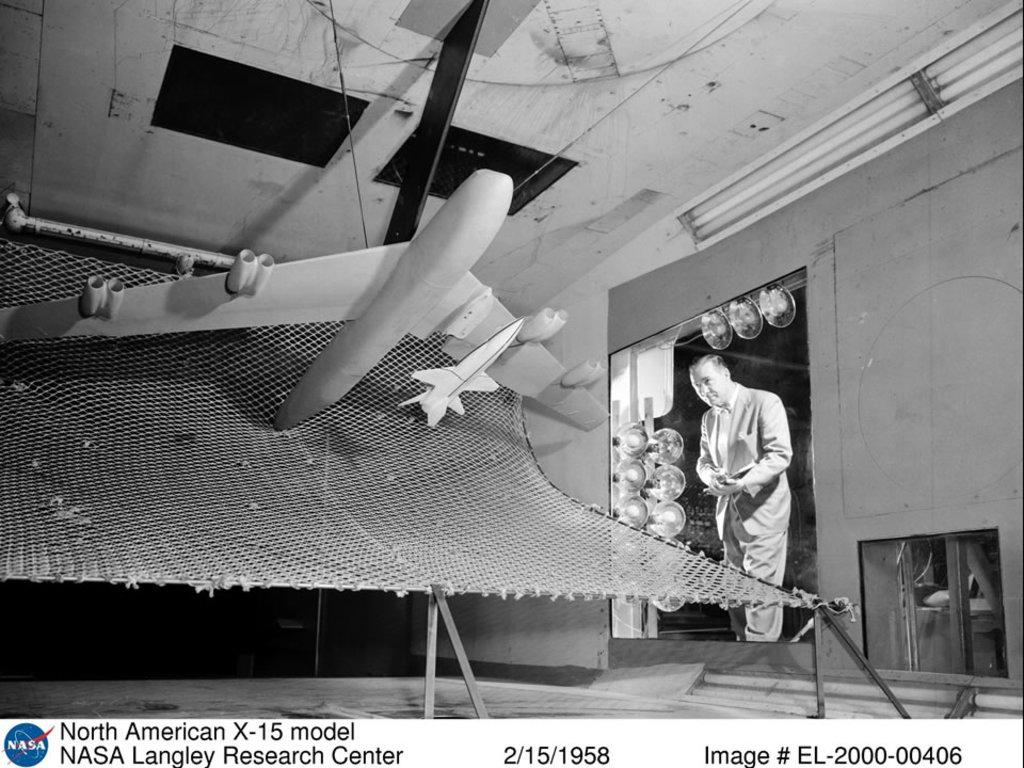<image>
Offer a succinct explanation of the picture presented. Airplane model from Nasa dated on 2/15/1958 that includes image # EL-2000-00406. 